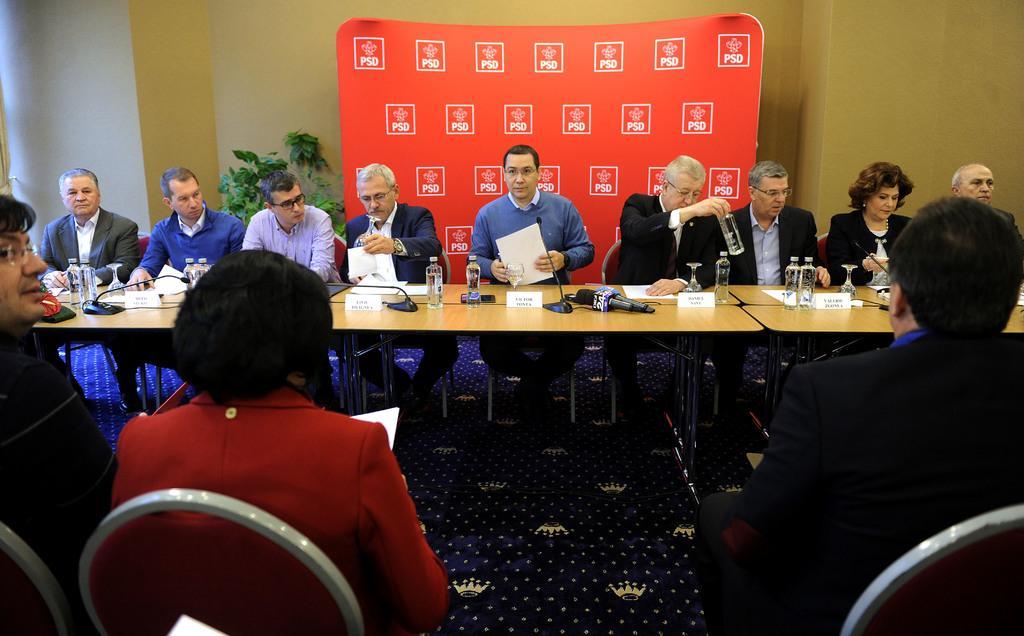Could you give a brief overview of what you see in this image? This picture describes about group of people, they are all seated on the chairs, in the middle of the image we can see few bottles, glasses, microphones and other things on the tables, in the background we can see a plant and a hoarding. 